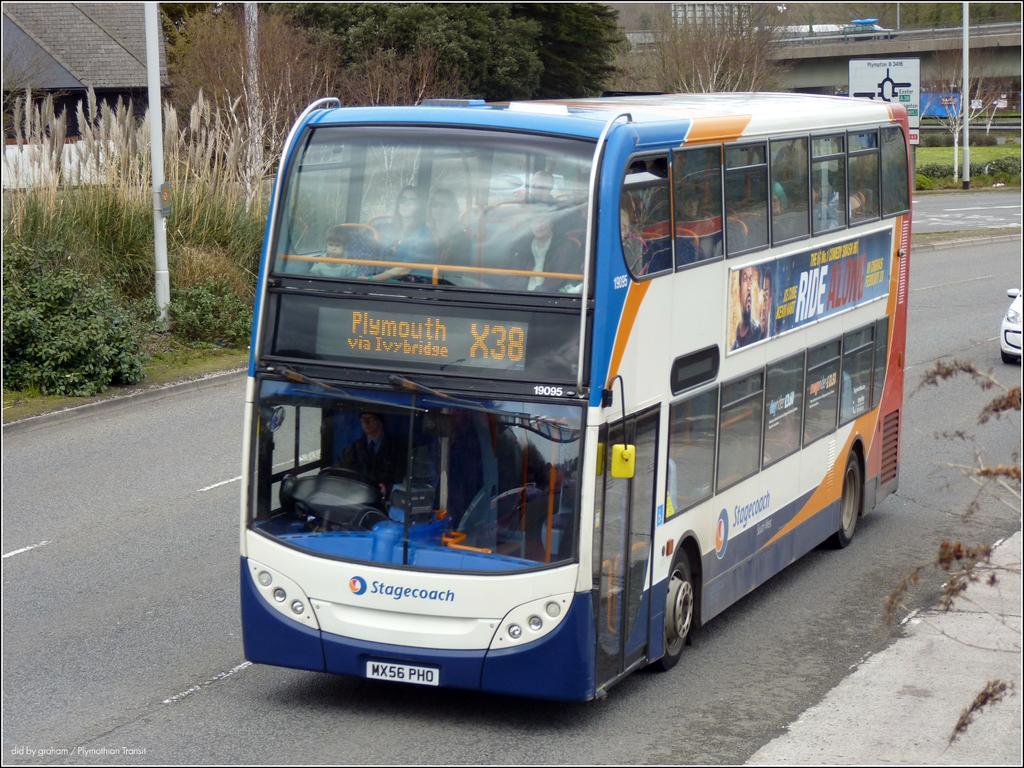Could you give a brief overview of what you see in this image? In this image in front there is a bus on the road. Inside the bus there are people. Behind the bus there is a car. On the right side of the image there is a tree. On the left side of the image there are poles, plants, trees, boards. There is a building. In the background of the image there is a car on the bridge. There is some text at the bottom of the image. 